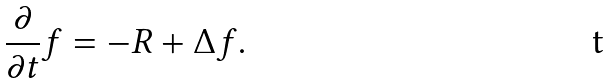<formula> <loc_0><loc_0><loc_500><loc_500>\frac { \partial } { \partial t } f = - R + \Delta f .</formula> 